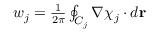Convert formula to latex. <formula><loc_0><loc_0><loc_500><loc_500>\begin{array} { r } { w _ { j } = { \frac { 1 } { 2 \pi } } \oint _ { C _ { j } } \nabla \chi _ { j } \cdot d { r } } \end{array}</formula> 